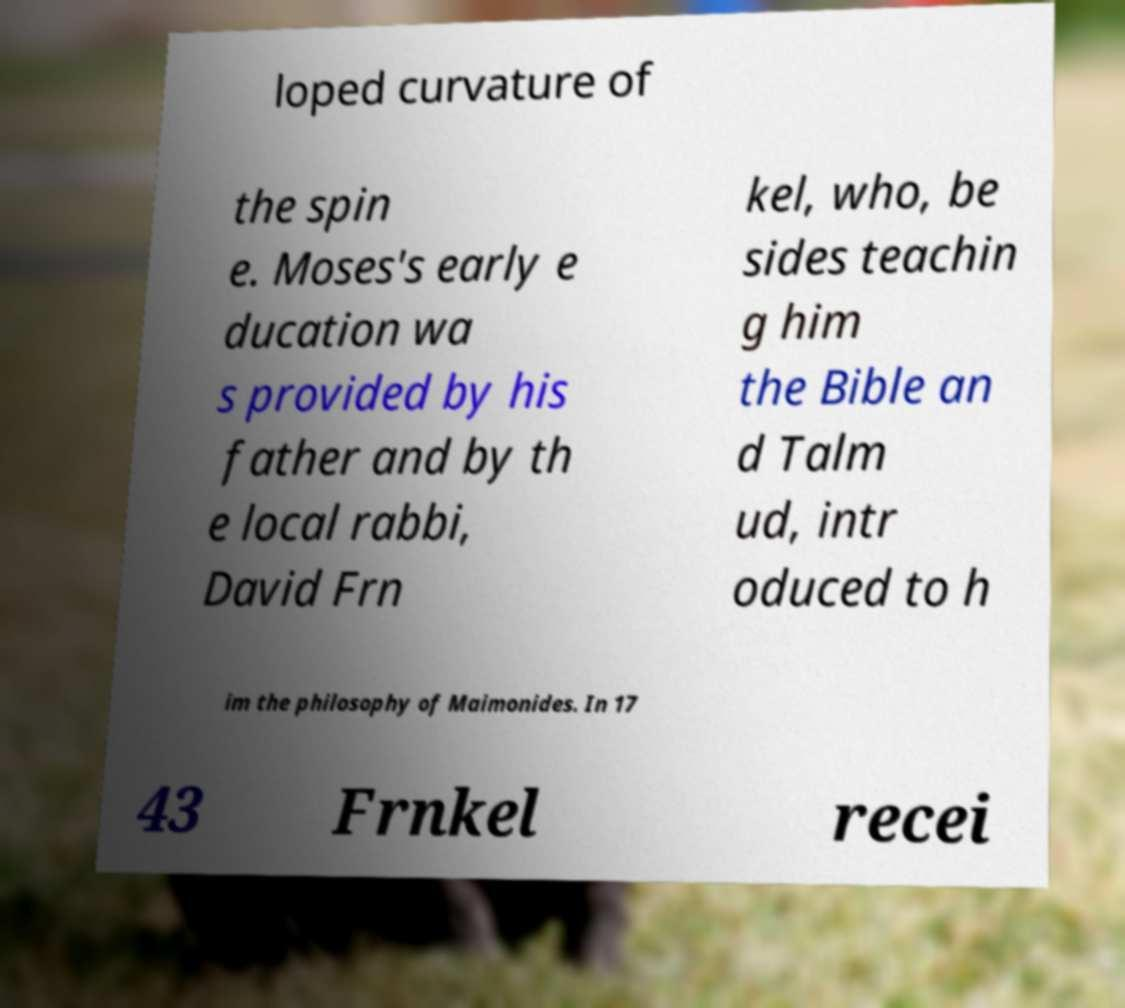I need the written content from this picture converted into text. Can you do that? loped curvature of the spin e. Moses's early e ducation wa s provided by his father and by th e local rabbi, David Frn kel, who, be sides teachin g him the Bible an d Talm ud, intr oduced to h im the philosophy of Maimonides. In 17 43 Frnkel recei 